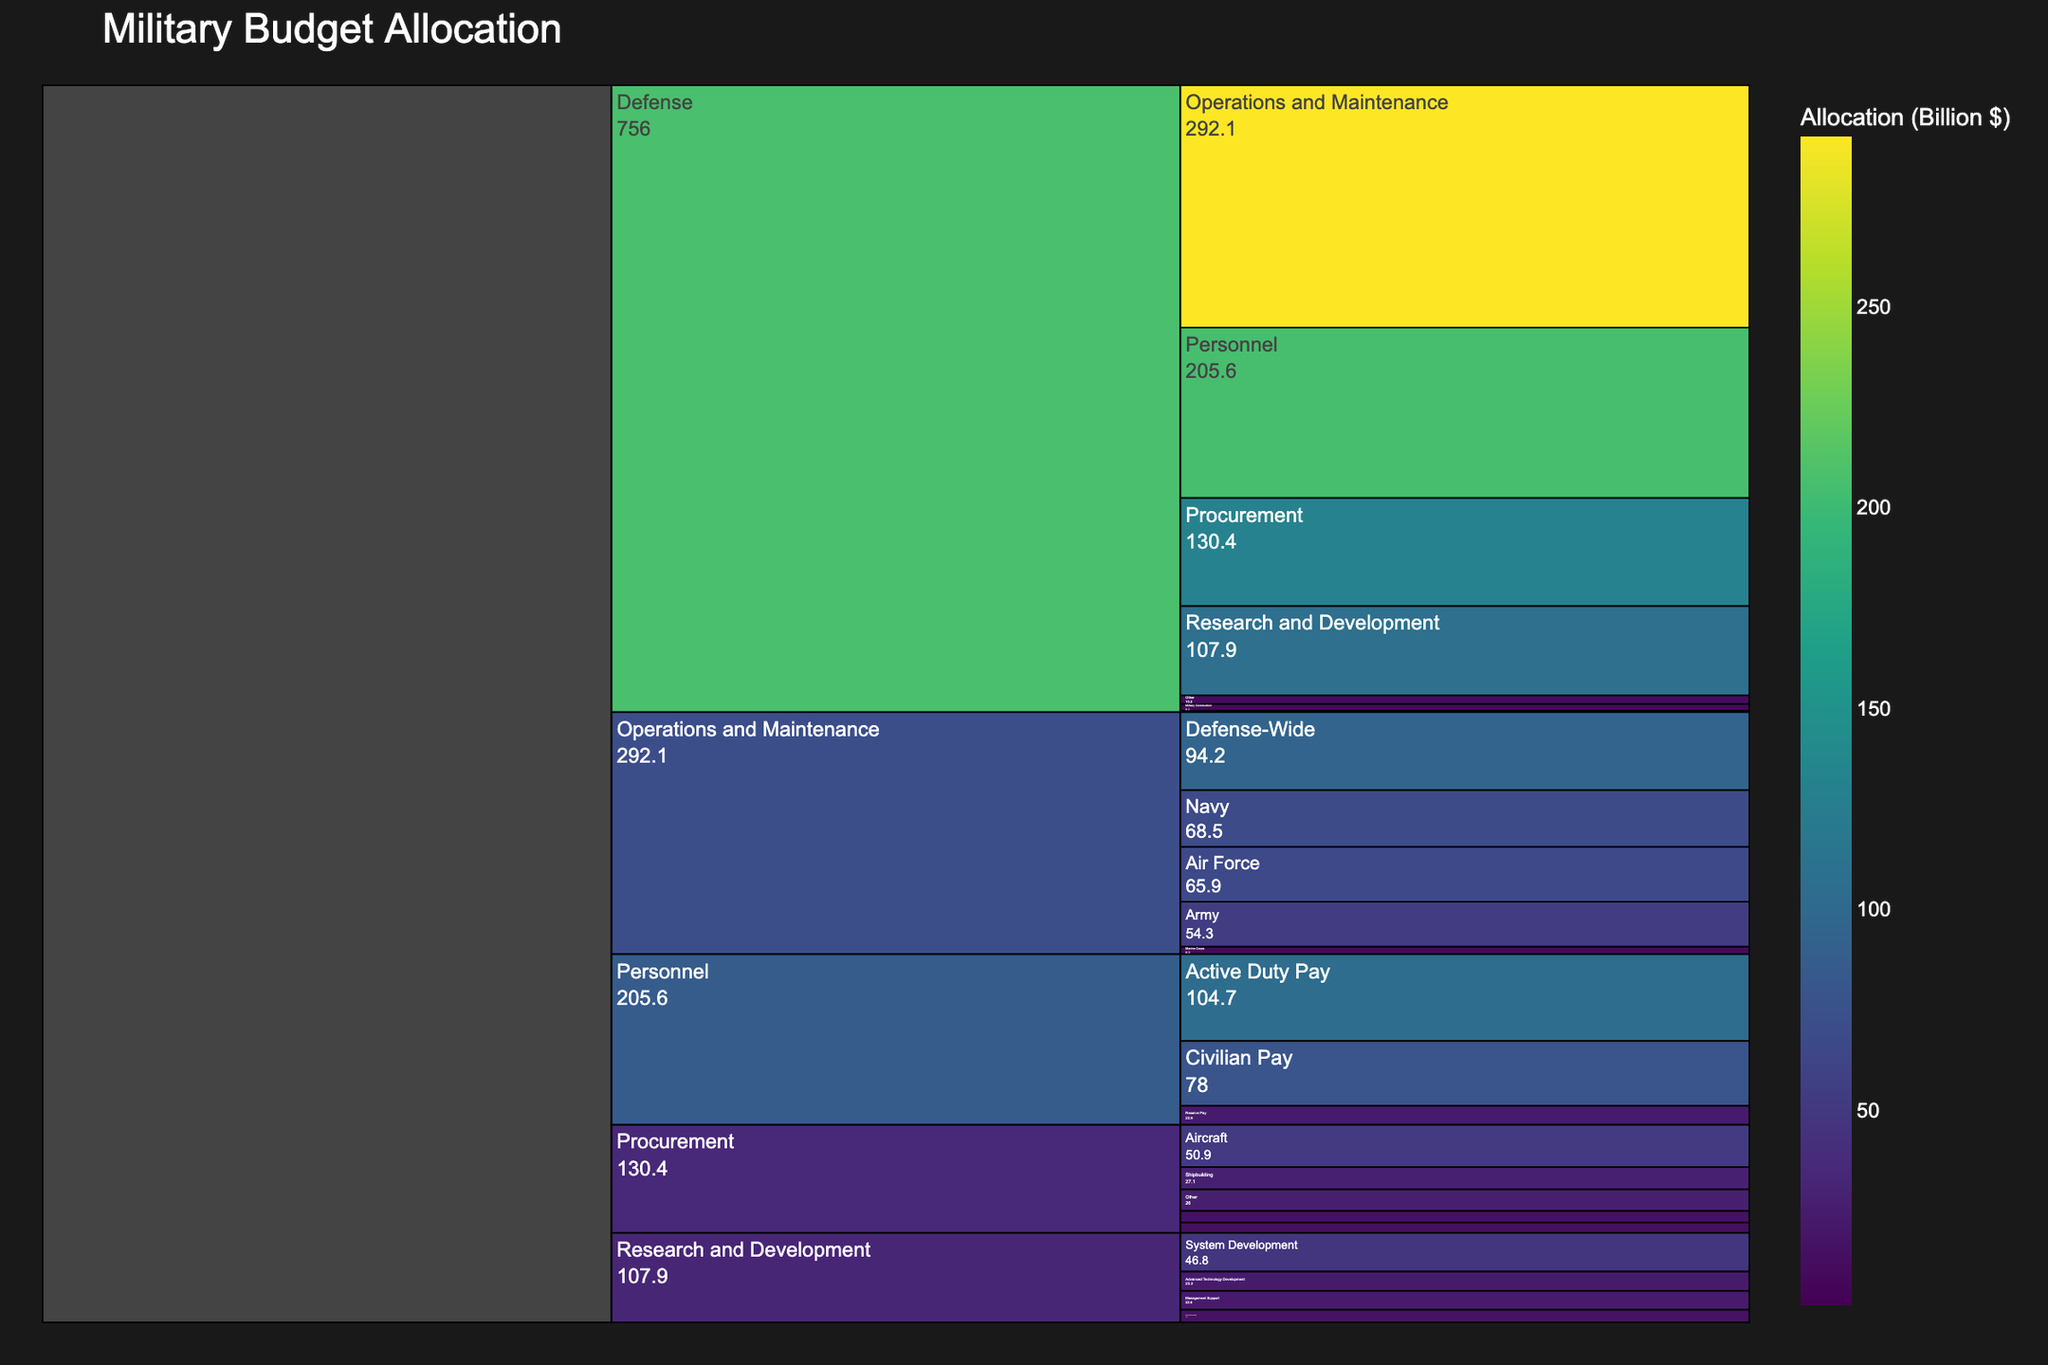What's the total budget allocated to the Defense Department? To find the total budget allocated to the Defense Department, sum up its individual components listed under "Program" which are: Personnel ($205.6B), Operations and Maintenance ($292.1B), Procurement ($130.4B), Research and Development ($107.9B), Military Construction ($8.4B), Family Housing ($1.4B), and Other ($10.2B). The calculation is 205.6 + 292.1 + 130.4 + 107.9 + 8.4 + 1.4 + 10.2.
Answer: $756.0 Billion Which department has the highest allocation within Operations and Maintenance? The categories under "Operations and Maintenance" are Army ($54.3B), Navy ($68.5B), Air Force ($65.9B), Marine Corps ($9.2B), and Defense-Wide ($94.2B). The highest among these is Defense-Wide with $94.2 Billion.
Answer: Defense-Wide How does the budget for Research and Development compare to the budget for Procurement? Compare the total allocations: Procurement ($130.4B) and Research and Development ($107.9B). Subtract Research and Development from Procurement: 130.4 - 107.9. This shows how much more is allocated to Procurement.
Answer: $22.5 Billion more What is the allocation for Active Duty Pay within the Personnel department? Within Personnel, Active Duty Pay has an allocation listed as $104.7 Billion.
Answer: $104.7 Billion What's the sum of allocations for Aircraft and Shipbuilding under the Procurement category? Within Procurement, Aircraft has $50.9B and Shipbuilding has $27.1B. Add these two values: 50.9 + 27.1.
Answer: $78.0 Billion Which program under Research and Development has the lowest budget allocation? The subcategories under Research and Development are: Science and Technology ($15.3B), Advanced Technology Development ($23.2B), System Development ($46.8B), and Management Support ($22.6B). The lowest allocation is for Science and Technology.
Answer: Science and Technology How many distinct programs are listed under the Defense Department? The distinct programs under Defense are: Personnel, Operations and Maintenance, Procurement, Research and Development, Military Construction, Family Housing, and Other. Count these to get the total number.
Answer: 7 programs What’s the difference in allocation between the Navy and the Army within Operations and Maintenance? Within Operations and Maintenance, Navy has $68.5B and Army has $54.3B. To find the difference, subtract Army's allocation from Navy's: 68.5 - 54.3.
Answer: $14.2 Billion Which program within the Procurement department gets the highest budget allocation? Under Procurement, the programs are: Aircraft ($50.9B), Missiles ($12.6B), Weapons and Combat Vehicles ($13.8B), Shipbuilding ($27.1B), and Other ($26.0B). The highest allocation is for Aircraft.
Answer: Aircraft What is the percentage of the total Defense budget allocated to Operations and Maintenance? First, find the total Defense budget: $756.0 Billion. Then find the proportion for Operations and Maintenance: $292.1B/$756.0B. Multiply by 100 to get the percentage. (292.1/756.0) * 100 ≈ 38.63%
Answer: 38.63% 